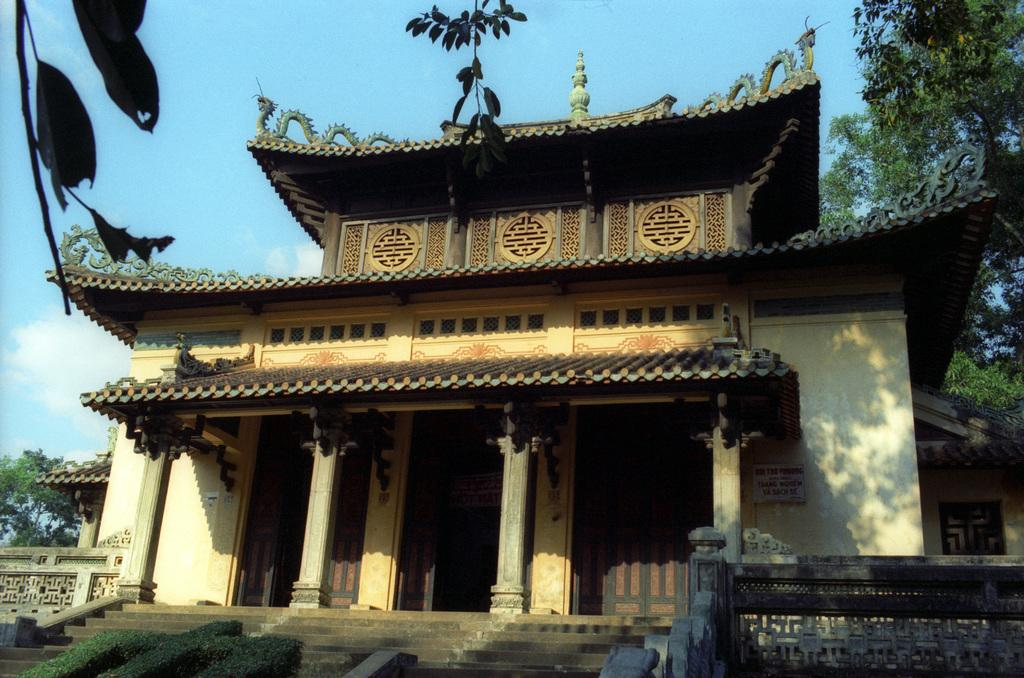What type of structure is present in the image? There is a building in the image. What are the walls in the image made of? The walls in the image are not specified, but they are likely made of a solid material like brick or concrete. What type of vegetation can be seen in the image? There are trees and bushes in the image. What is visible in the background of the image? The sky is visible in the background of the image. How does the ship navigate through the walls in the image? There is no ship present in the image; it only features a building, walls, trees, bushes, and the sky. 